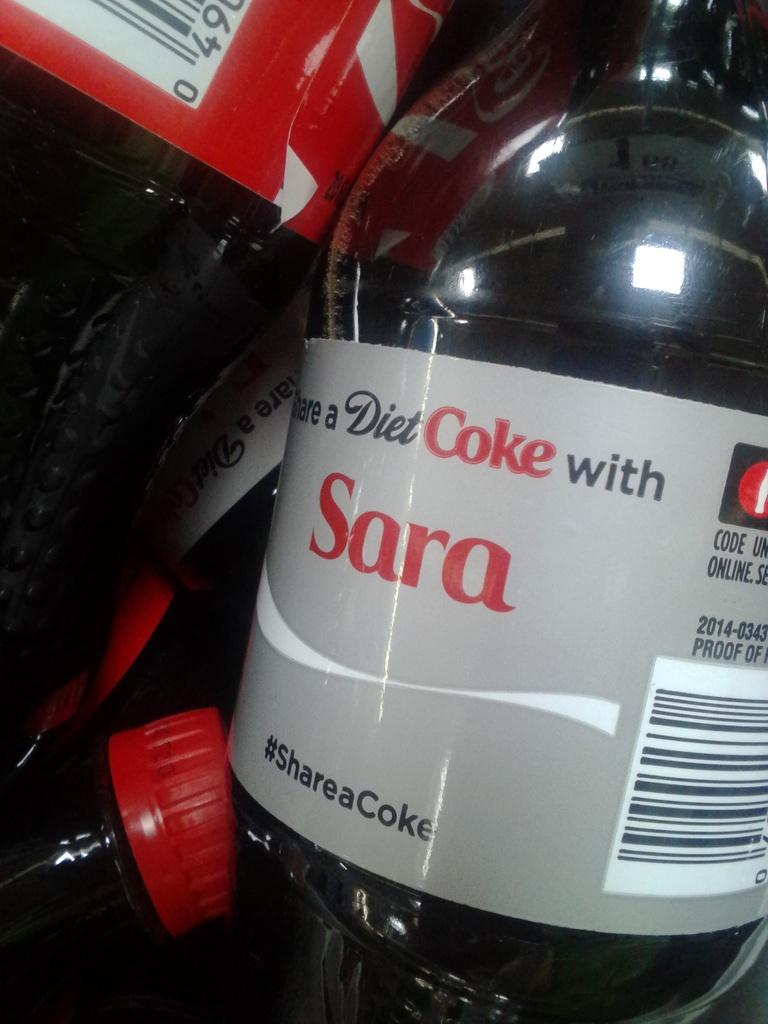What type of beverage is contained in the bottles in the image? The bottles in the image contain coke. What color are the caps on the bottles? The caps on the bottles have a red color. Are there any additional decorations or markings on the bottles? Yes, there are stickers on the bottles. What type of attack can be seen in the image involving the bottles of coke? There is no attack present in the image; it simply shows bottles of coke with red caps and stickers. 